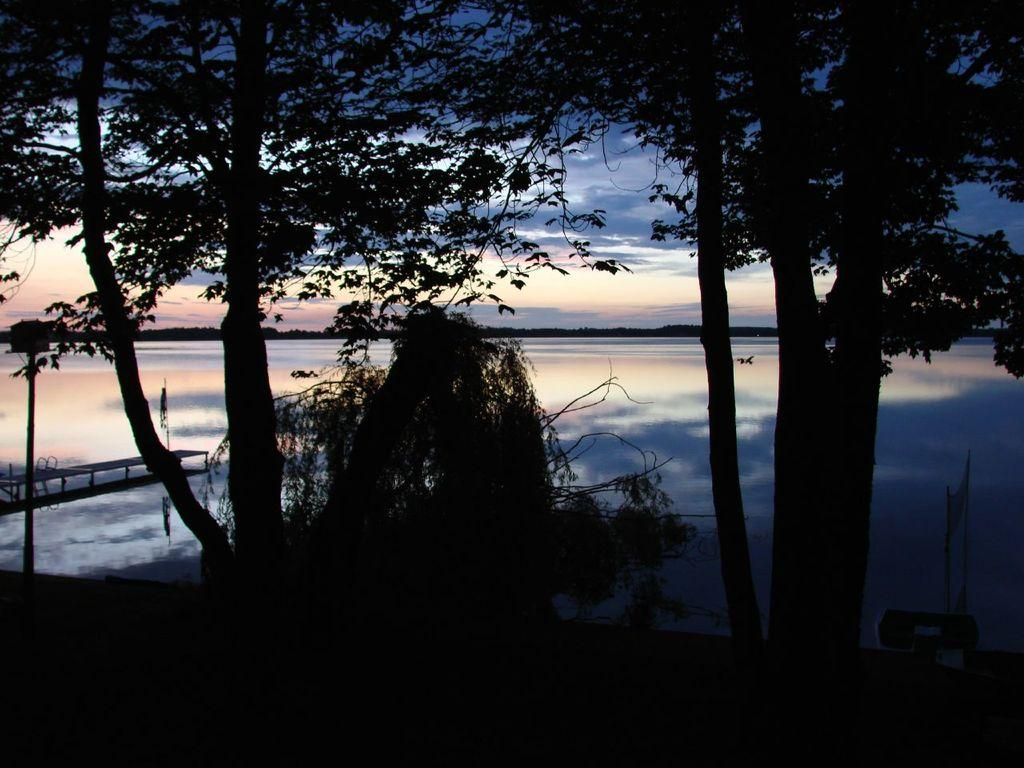What type of vegetation can be seen in the image? There are trees and plants visible in the image. What is located at the bottom of the image? There are objects at the bottom of the image. What is the primary element visible in the image? Water is visible in the image. Where is the platform located in the image? The platform is on the left side of the image. What is present in the background of the image? In the background, there is water, objects, and clouds in the sky visible. How many bears can be seen on the platform in the image? There are no bears present in the image; the platform is empty. What type of pest is causing problems for the vacationers in the image? There is no indication of vacationers or pests in the image. 